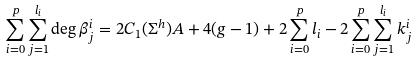<formula> <loc_0><loc_0><loc_500><loc_500>\sum _ { i = 0 } ^ { p } \sum _ { j = 1 } ^ { l _ { i } } \deg \beta _ { j } ^ { i } = 2 C _ { 1 } ( \Sigma ^ { h } ) A + 4 ( g - 1 ) + 2 \sum _ { i = 0 } ^ { p } l _ { i } - 2 \sum _ { i = 0 } ^ { p } \sum _ { j = 1 } ^ { l _ { i } } k _ { j } ^ { i }</formula> 